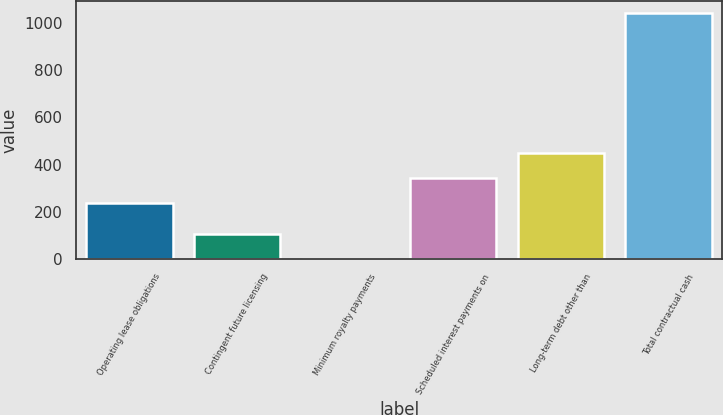Convert chart. <chart><loc_0><loc_0><loc_500><loc_500><bar_chart><fcel>Operating lease obligations<fcel>Contingent future licensing<fcel>Minimum royalty payments<fcel>Scheduled interest payments on<fcel>Long-term debt other than<fcel>Total contractual cash<nl><fcel>236.5<fcel>105.7<fcel>1.8<fcel>343<fcel>446.9<fcel>1040.8<nl></chart> 